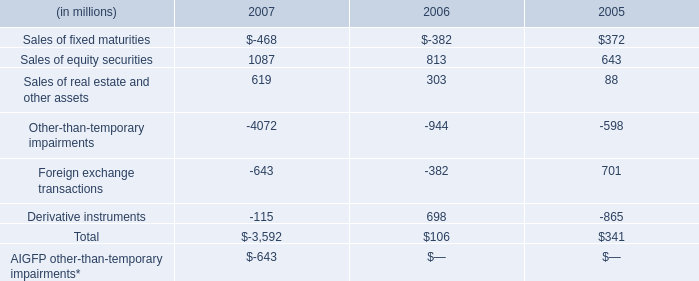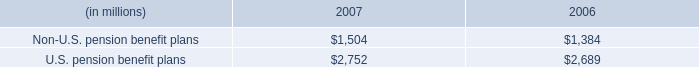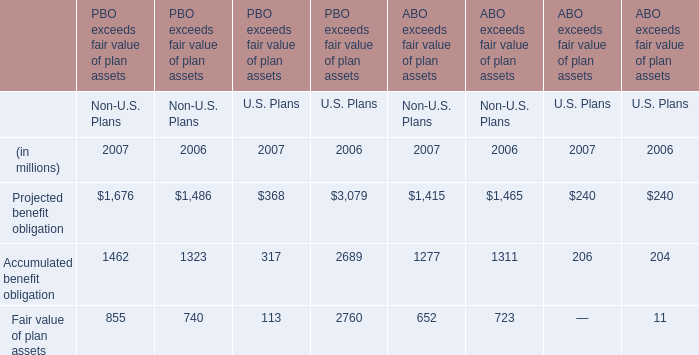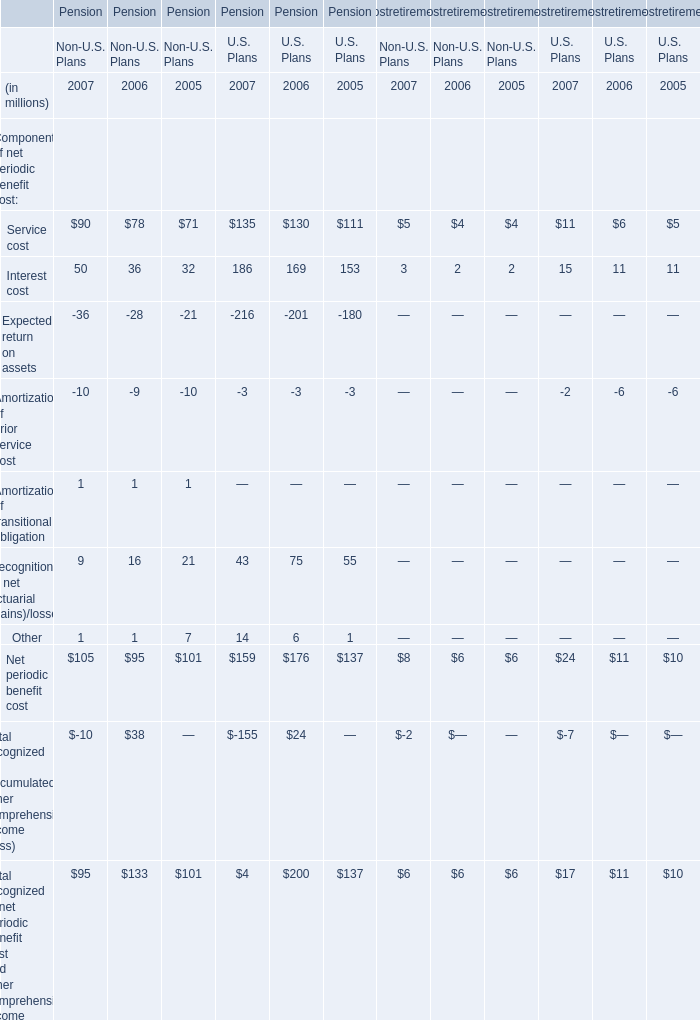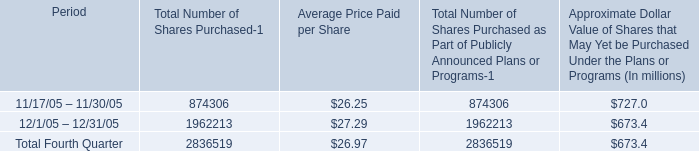What is the growing rate of U.S. pension benefit plans in the year with the most Non-U.S. pension benefit plans? (in %) 
Computations: ((2752 - 2689) / 2689)
Answer: 0.02343. 